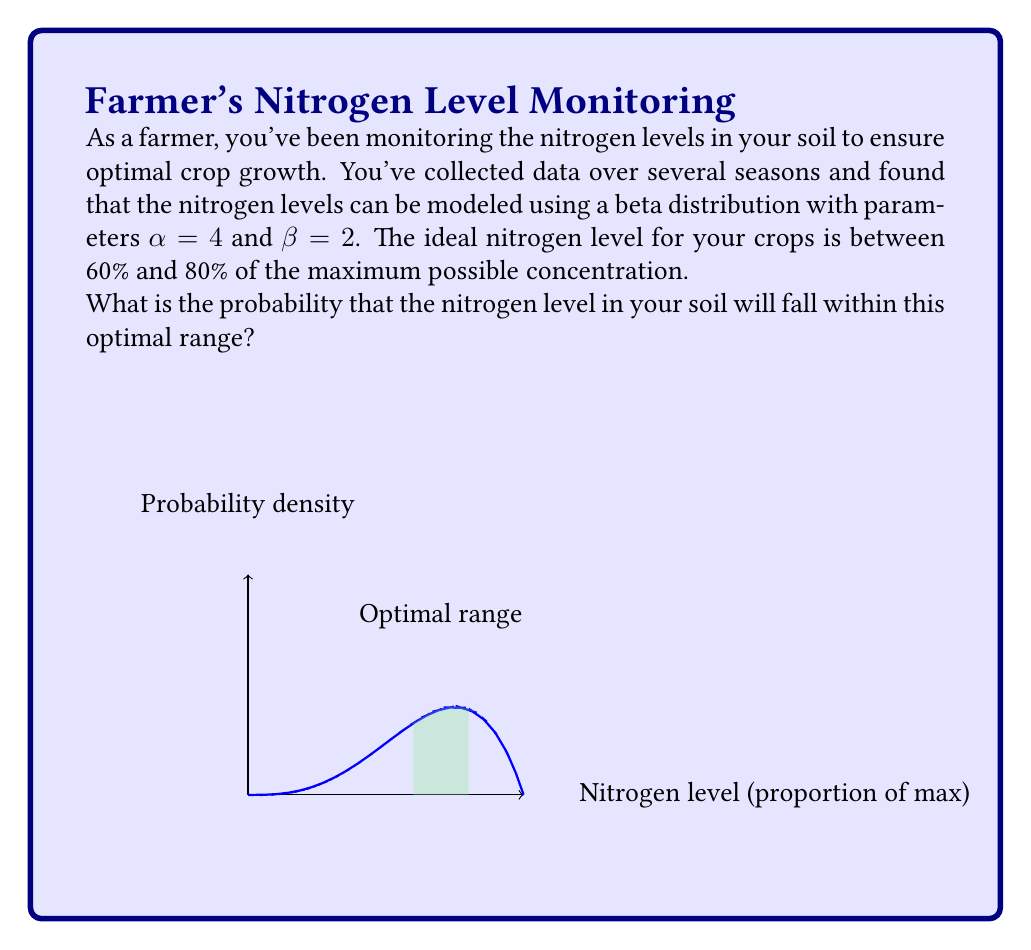Show me your answer to this math problem. Let's approach this step-by-step:

1) The beta distribution with parameters α = 4 and β = 2 has the probability density function:

   $$f(x) = \frac{x^{3}(1-x)}{B(4,2)}$$

   where B(4,2) is the beta function.

2) To find the probability of the nitrogen level falling between 60% and 80%, we need to integrate this function from 0.6 to 0.8:

   $$P(0.6 \leq X \leq 0.8) = \int_{0.6}^{0.8} \frac{x^{3}(1-x)}{B(4,2)} dx$$

3) This integral is complex to solve by hand, so we'll use the cumulative distribution function (CDF) of the beta distribution, which is often denoted as I_x(α,β).

4) The probability we're looking for is:

   $$P(0.6 \leq X \leq 0.8) = I_{0.8}(4,2) - I_{0.6}(4,2)$$

5) Using a statistical calculator or software:
   
   $$I_{0.8}(4,2) \approx 0.8192$$
   $$I_{0.6}(4,2) \approx 0.4752$$

6) Therefore:

   $$P(0.6 \leq X \leq 0.8) = 0.8192 - 0.4752 = 0.3440$$

7) Converting to a percentage:

   $$0.3440 * 100\% = 34.40\%$$

Thus, there is approximately a 34.40% chance that the nitrogen level in your soil will fall within the optimal range.
Answer: 34.40% 